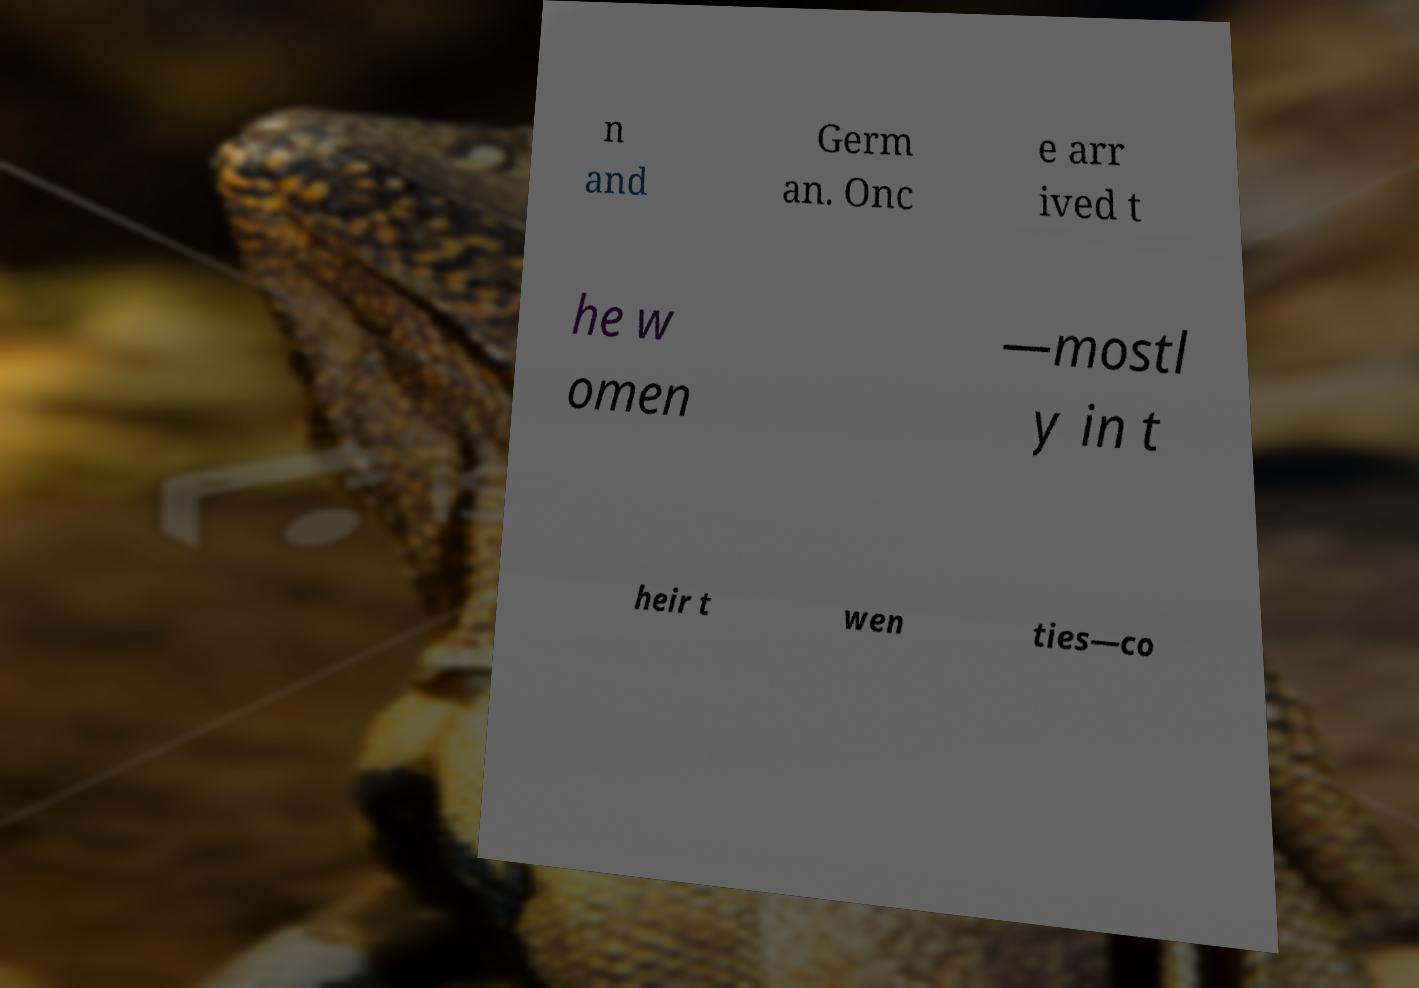Can you accurately transcribe the text from the provided image for me? n and Germ an. Onc e arr ived t he w omen —mostl y in t heir t wen ties—co 